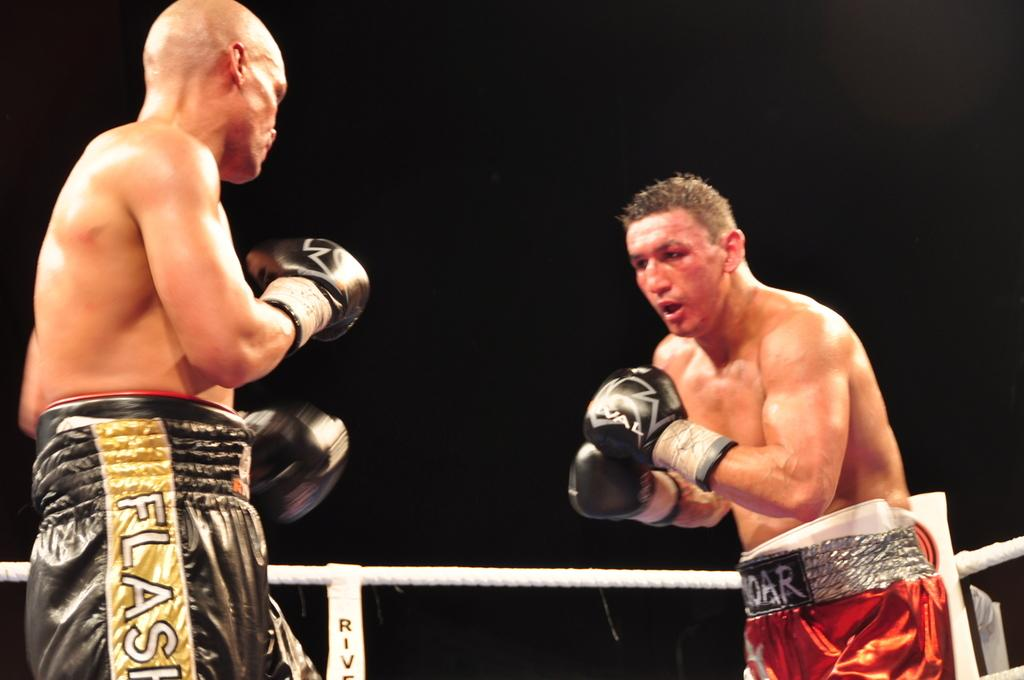How many people are in the image? There are two persons in the image. What are the two persons doing? The two persons are boxing. What can be seen in the image besides the two persons? There is a rope in the image. What is the color of the background in the image? The background of the image is dark. What type of hill can be seen in the background of the image? There is no hill visible in the image; the background is dark. What advice might the dad give to the two persons in the image? There is no dad present in the image, so it's not possible to determine what advice he might give. 